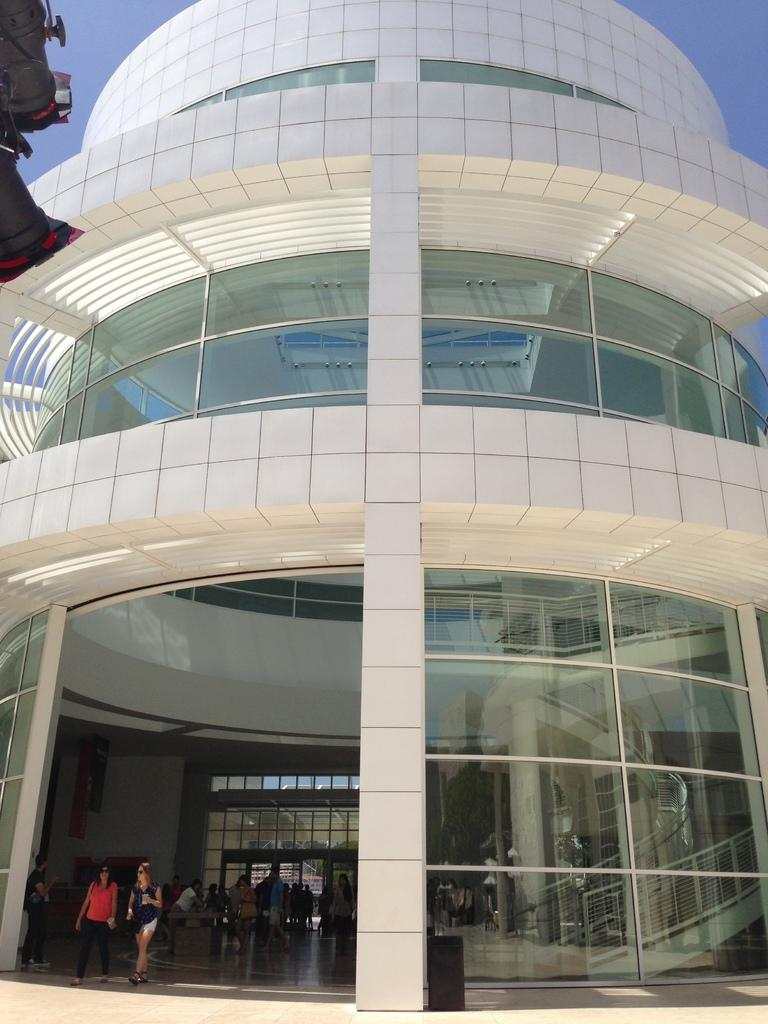What is the main structure in the image? There is a building in the image. What are the people in the building doing? The people in the building are standing and walking. What can be seen behind the building? The sky is visible behind the building. What color is the orange hanging from the bulb in the image? There is no orange or bulb present in the image. 